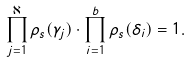Convert formula to latex. <formula><loc_0><loc_0><loc_500><loc_500>\prod _ { j = 1 } ^ { \aleph } \rho _ { s } ( \gamma _ { j } ) \cdot \prod _ { i = 1 } ^ { b } \rho _ { s } ( \delta _ { i } ) = 1 .</formula> 